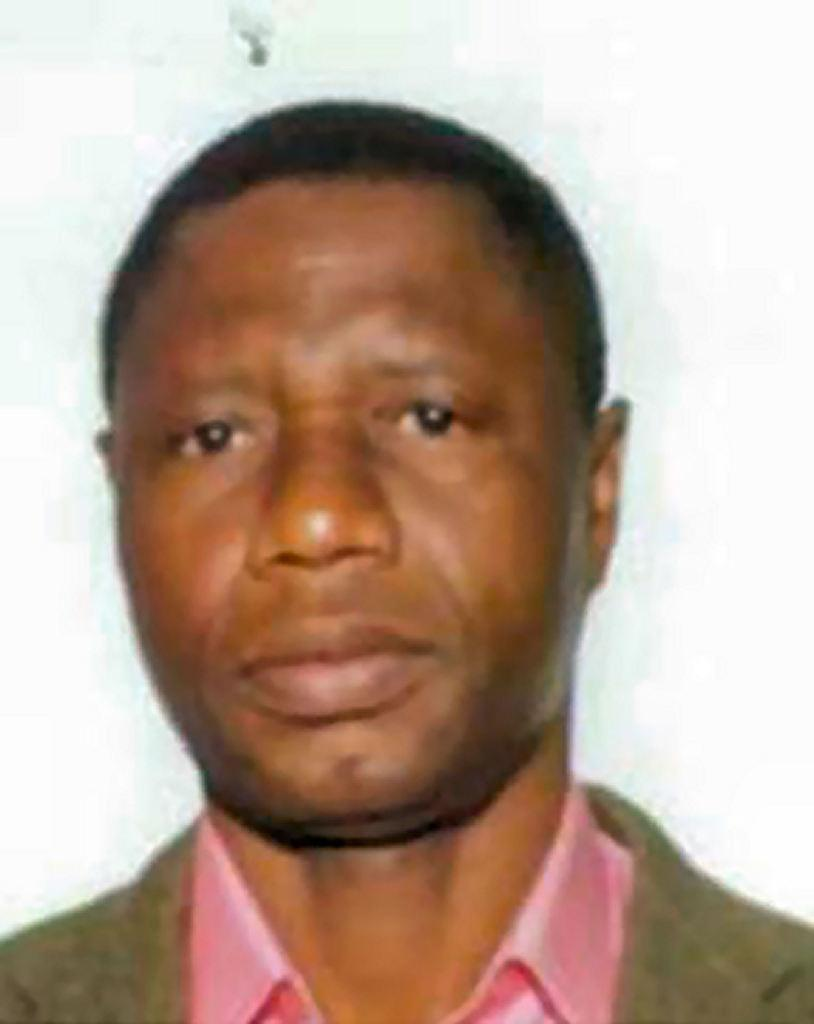What is the main subject of the image? The main subject of the image is a man. Can you describe the man in the image? Unfortunately, the provided facts do not include any details about the man's appearance or clothing. What is the context of the image? The context of the image is not mentioned in the provided facts. What type of rice is being cooked in the background of the image? There is no rice present in the image, as it is a photograph of a man. How does the acoustics of the room affect the man's voice in the image? The provided facts do not mention any audio or sound in the image, so it is impossible to determine the acoustics of the room or how it might affect the man's voice. 